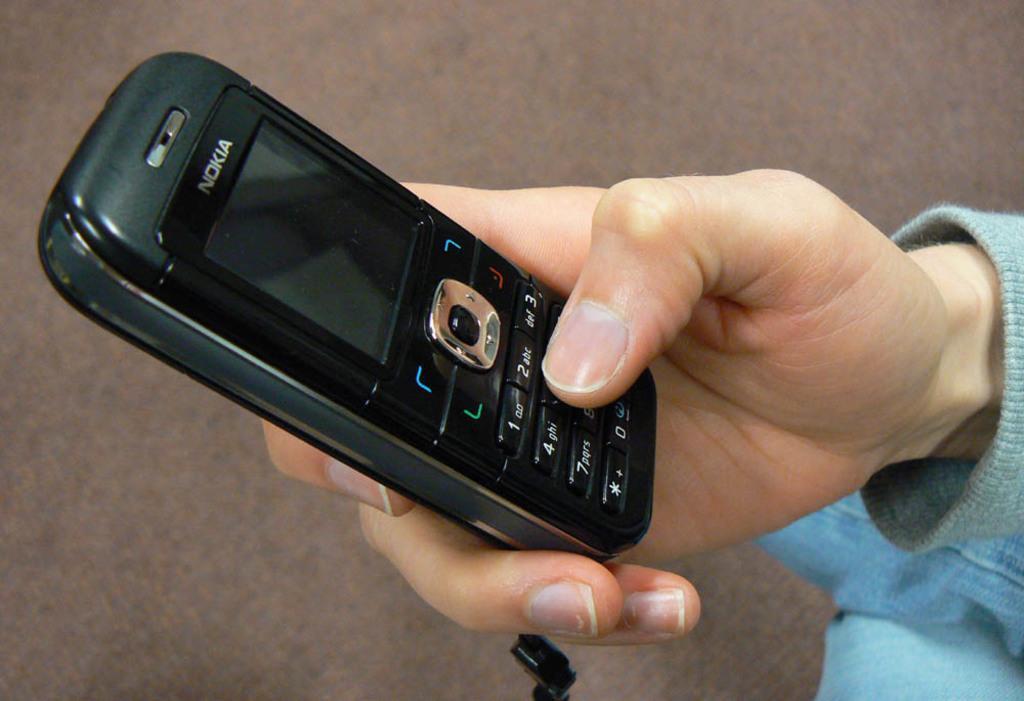In one or two sentences, can you explain what this image depicts? This image consists of a hand of a person. They are holding mobile phone. 